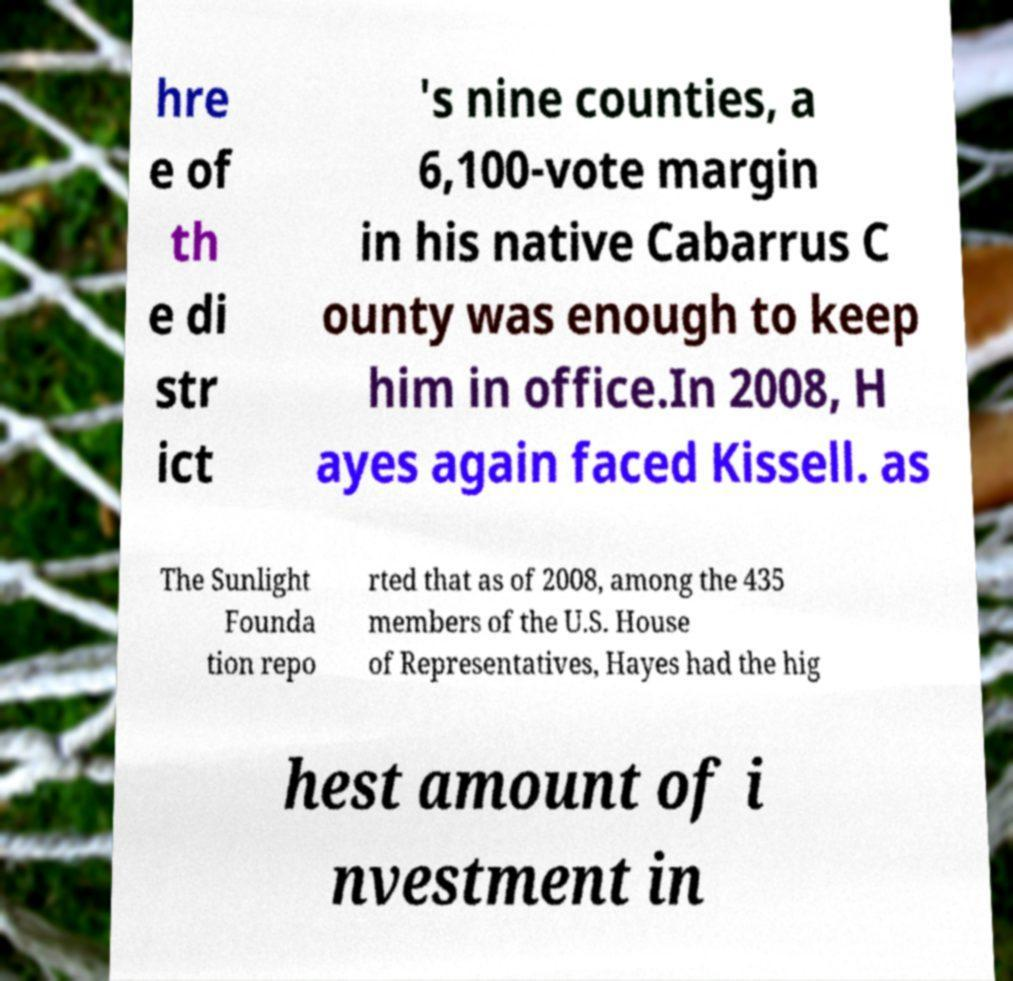Can you accurately transcribe the text from the provided image for me? hre e of th e di str ict 's nine counties, a 6,100-vote margin in his native Cabarrus C ounty was enough to keep him in office.In 2008, H ayes again faced Kissell. as The Sunlight Founda tion repo rted that as of 2008, among the 435 members of the U.S. House of Representatives, Hayes had the hig hest amount of i nvestment in 